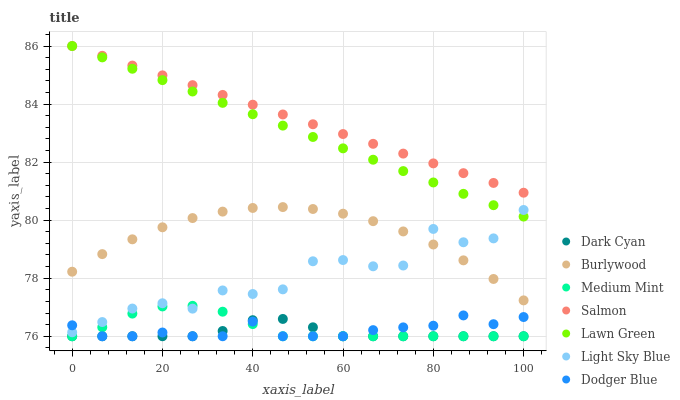Does Dark Cyan have the minimum area under the curve?
Answer yes or no. Yes. Does Salmon have the maximum area under the curve?
Answer yes or no. Yes. Does Lawn Green have the minimum area under the curve?
Answer yes or no. No. Does Lawn Green have the maximum area under the curve?
Answer yes or no. No. Is Lawn Green the smoothest?
Answer yes or no. Yes. Is Light Sky Blue the roughest?
Answer yes or no. Yes. Is Burlywood the smoothest?
Answer yes or no. No. Is Burlywood the roughest?
Answer yes or no. No. Does Medium Mint have the lowest value?
Answer yes or no. Yes. Does Lawn Green have the lowest value?
Answer yes or no. No. Does Salmon have the highest value?
Answer yes or no. Yes. Does Burlywood have the highest value?
Answer yes or no. No. Is Dark Cyan less than Light Sky Blue?
Answer yes or no. Yes. Is Burlywood greater than Dark Cyan?
Answer yes or no. Yes. Does Lawn Green intersect Salmon?
Answer yes or no. Yes. Is Lawn Green less than Salmon?
Answer yes or no. No. Is Lawn Green greater than Salmon?
Answer yes or no. No. Does Dark Cyan intersect Light Sky Blue?
Answer yes or no. No. 